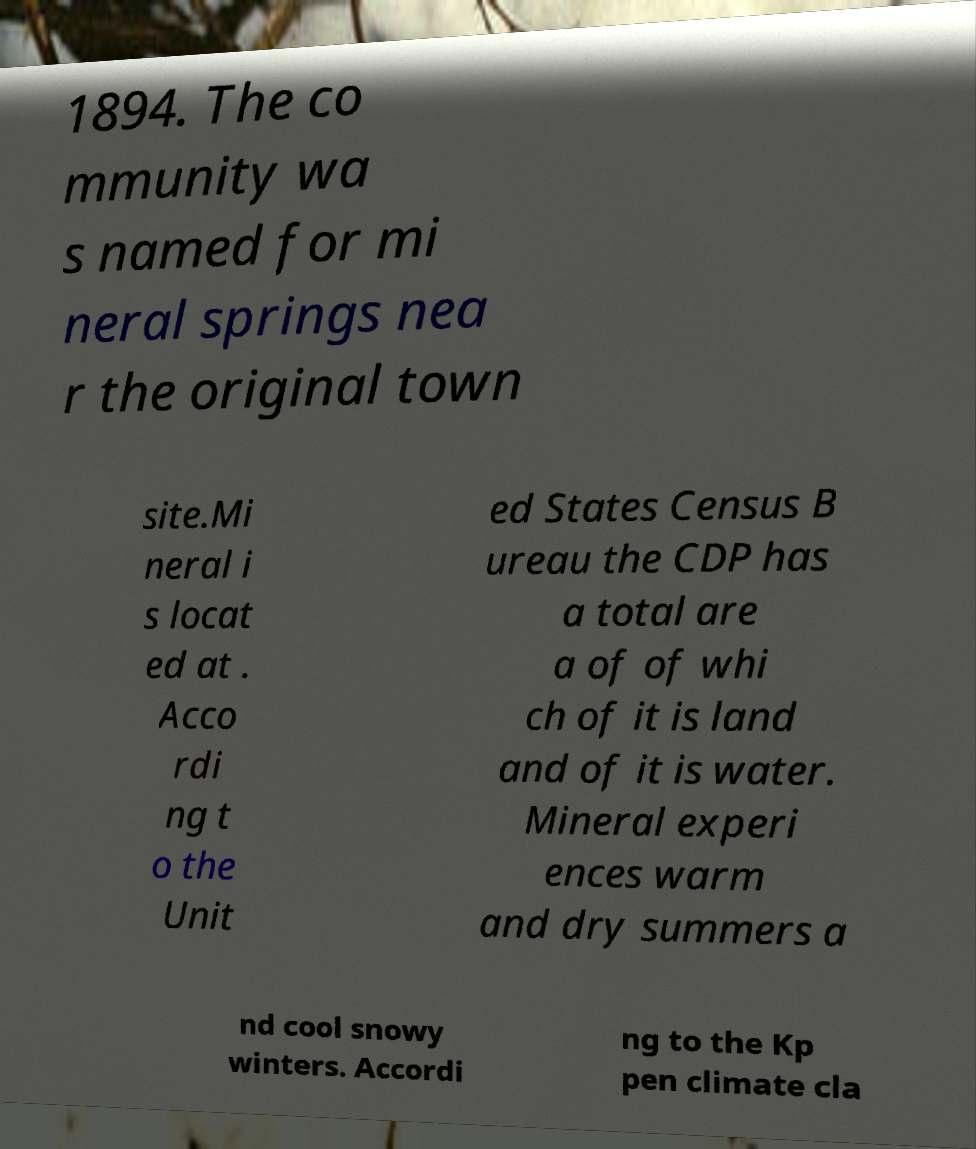Please read and relay the text visible in this image. What does it say? 1894. The co mmunity wa s named for mi neral springs nea r the original town site.Mi neral i s locat ed at . Acco rdi ng t o the Unit ed States Census B ureau the CDP has a total are a of of whi ch of it is land and of it is water. Mineral experi ences warm and dry summers a nd cool snowy winters. Accordi ng to the Kp pen climate cla 